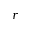<formula> <loc_0><loc_0><loc_500><loc_500>r</formula> 